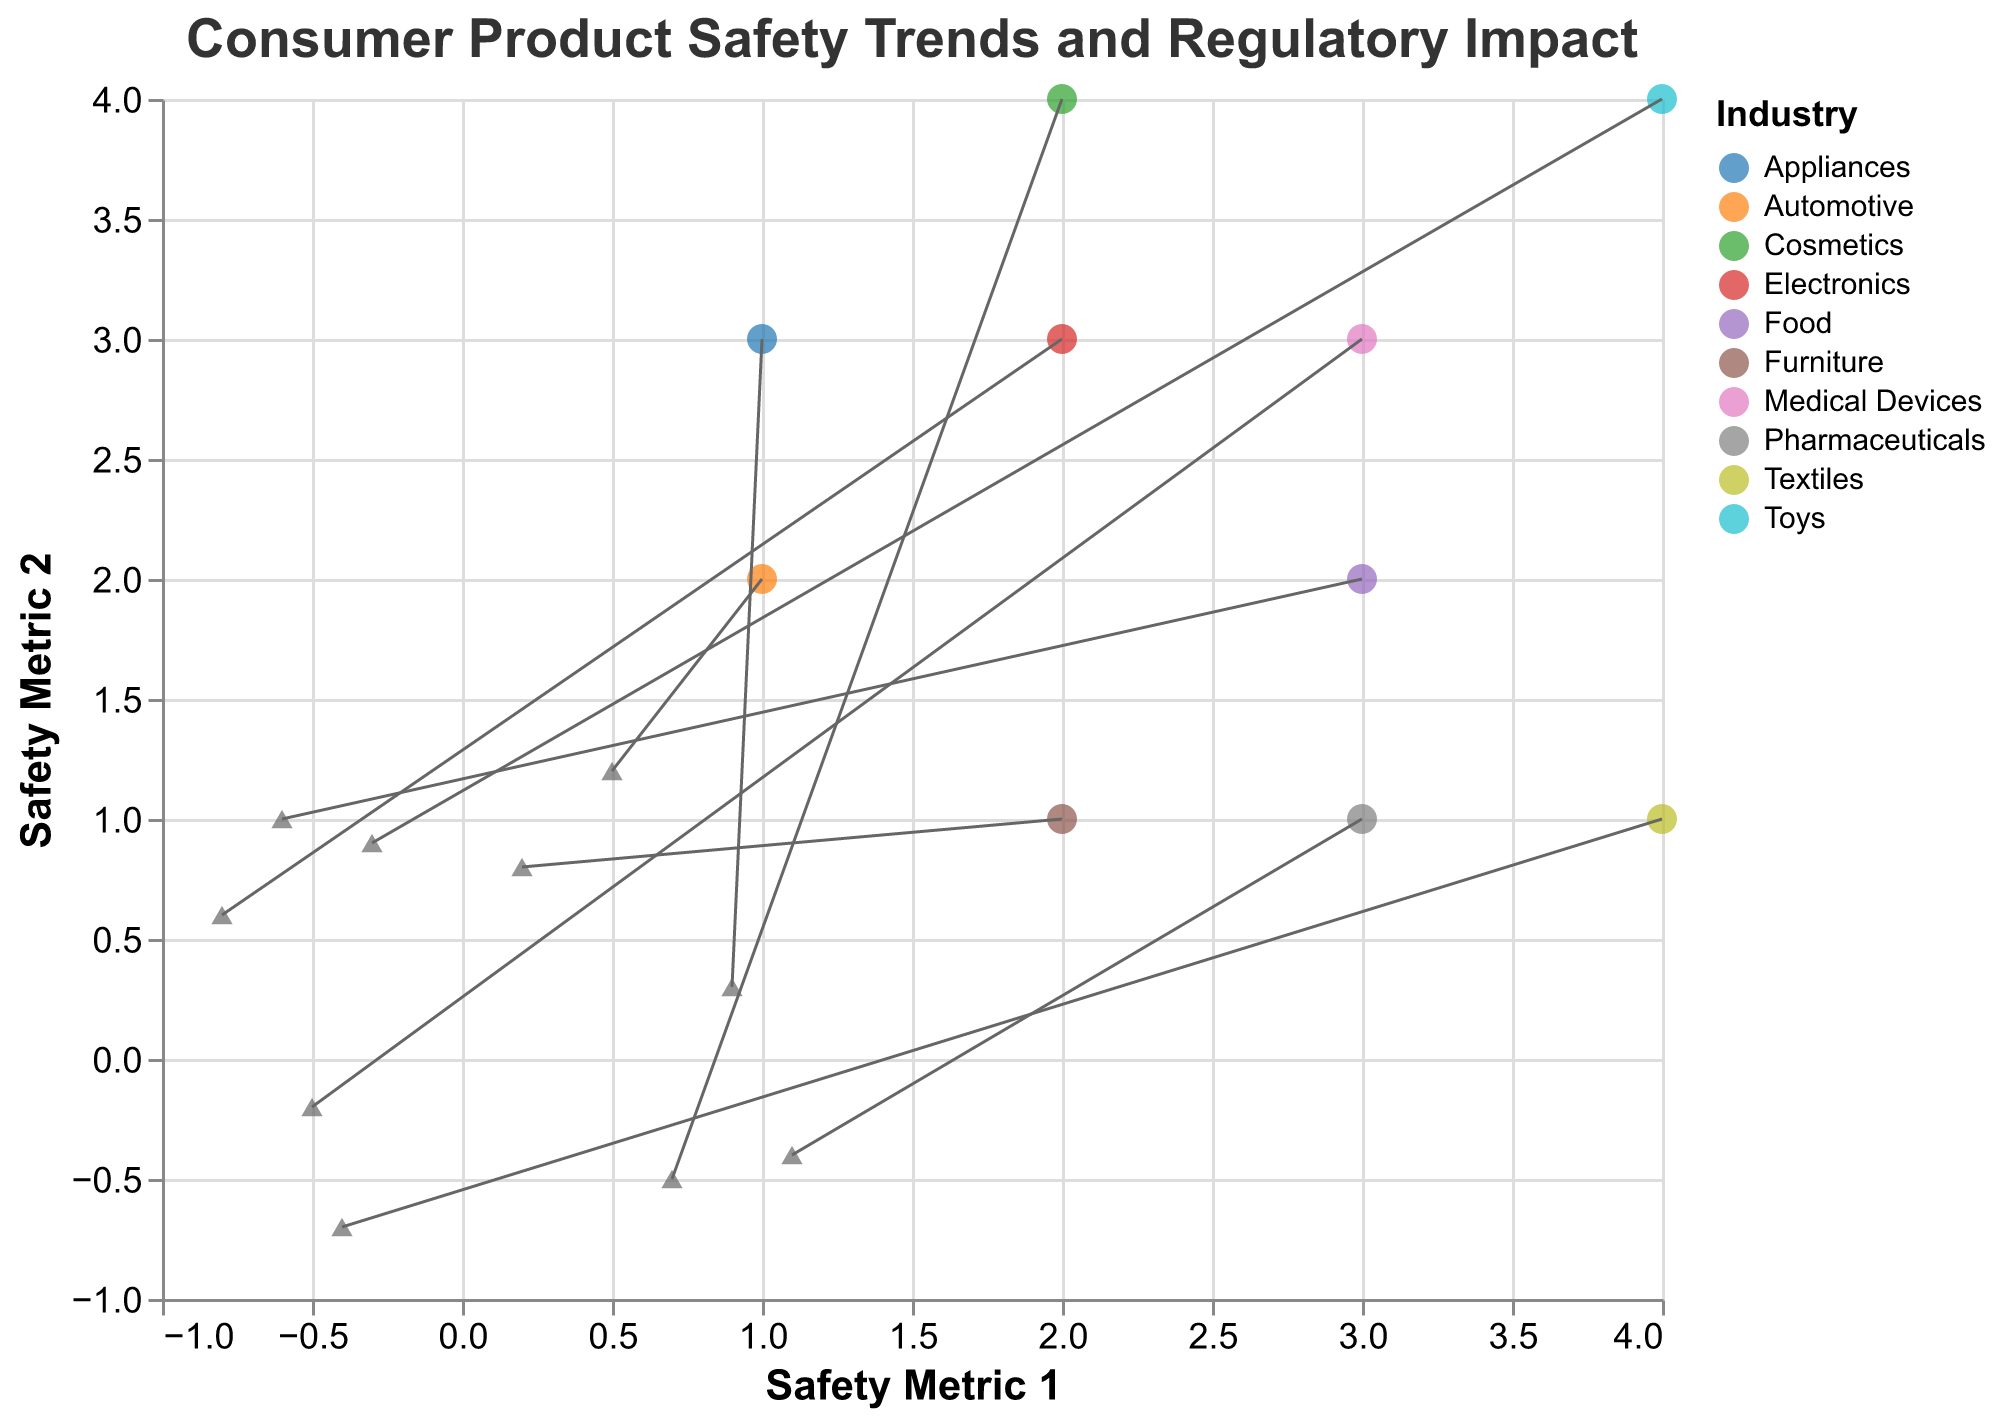Which industry has the highest y-value? To find the industry with the highest y-value, look for the data point with the highest position on the y-axis. The highest y-value is at y=4, belonging to the "Toys" industry.
Answer: Toys What is the color scheme used to differentiate the industries? Observe the color legend on the figure which depicts different colors for each industry. The color scheme used is "category10" which includes 10 distinct colors.
Answer: category10 Which regulatory body is associated with the Pharmaceutical industry? Look at the tooltip information from the figure. For the Pharmaceutical industry, the tooltip shows "Regulatory Body: FDA".
Answer: FDA How many industries are represented in the figure? Count the distinct industries listed in the color legend of the plot. There are ten unique industries represented.
Answer: 10 Compare the vector lengths between the Automotive and Pharmaceuticals industries. Which is longer? Calculate the vector length using the formula sqrt(u^2 + v^2). For Automotive: sqrt(0.5^2 + 1.2^2) ≈1.3. For Pharmaceuticals: sqrt(1.1^2 + 0.4^2) ≈1.17. Therefore, the Automotive industry's vector is longer.
Answer: Automotive Which industry has the most negative x-directional component (u)? Check the u-values for all industries and identify the most negative value. The value -0.8 for Electronics is the most negative x-directional component.
Answer: Electronics What is the average y-value of all the industries? Add all y-values (2+3+1+4+4+2+3+1+1+3 = 24) and divide by the number of data points (10) to get the average y-value. 24/10 = 2.4.
Answer: 2.4 How does the direction of the vector for Toys differ from that of Textiles? The Toys vector has components (-0.3, 0.9) indicating it points primarily up-left, while the Textiles vector has components (-0.4, -0.7) indicating it points primarily down-left which is opposite in the y-direction.
Answer: Toys: up-left, Textiles: down-left What is the regulatory body associated with the highest x-value? The highest x-value is 4, and the industry with this value is "Toys". The associated regulatory body for Toys is "CPSC".
Answer: CPSC 